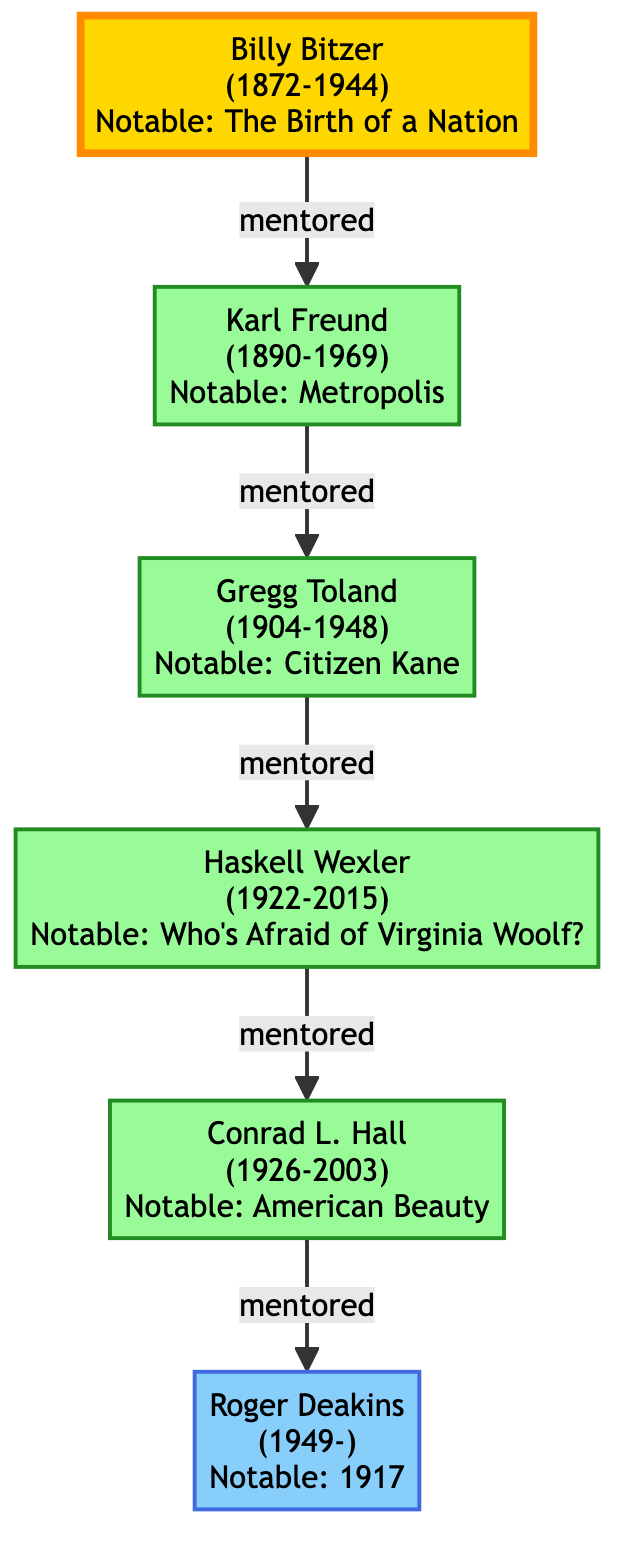What is the birth year of Billy Bitzer? The diagram states that Billy Bitzer was born in 1872.
Answer: 1872 How many notable works are associated with Karl Freund? The diagram lists two notable works for Karl Freund: "Metropolis" and "Dracula," which totals to two works.
Answer: 2 Who mentored Roger Deakins? Following the mentor-mentee relationship shown in the diagram, we see that Conrad L. Hall mentored Roger Deakins.
Answer: Conrad L. Hall Which year did Haskell Wexler die? The diagram indicates that Haskell Wexler died in 2015.
Answer: 2015 Name one notable work by Gregg Toland. The diagram shows that one of the notable works by Gregg Toland is "Citizen Kane."
Answer: Citizen Kane Who is the root of this family tree? The diagram identifies Billy Bitzer as the root of the family tree, as he is the earliest figure depicted.
Answer: Billy Bitzer How many generations of cinematographers are displayed in the diagram? The diagram presents five generations, starting from Billy Bitzer down to Roger Deakins.
Answer: 5 What is the relationship between Karl Freund and Gregg Toland? The diagram indicates that Karl Freund is the mentor of Gregg Toland, establishing a direct mentor-mentee relationship.
Answer: Mentor In what year was Conrad L. Hall born? According to the diagram, Conrad L. Hall was born in 1926.
Answer: 1926 